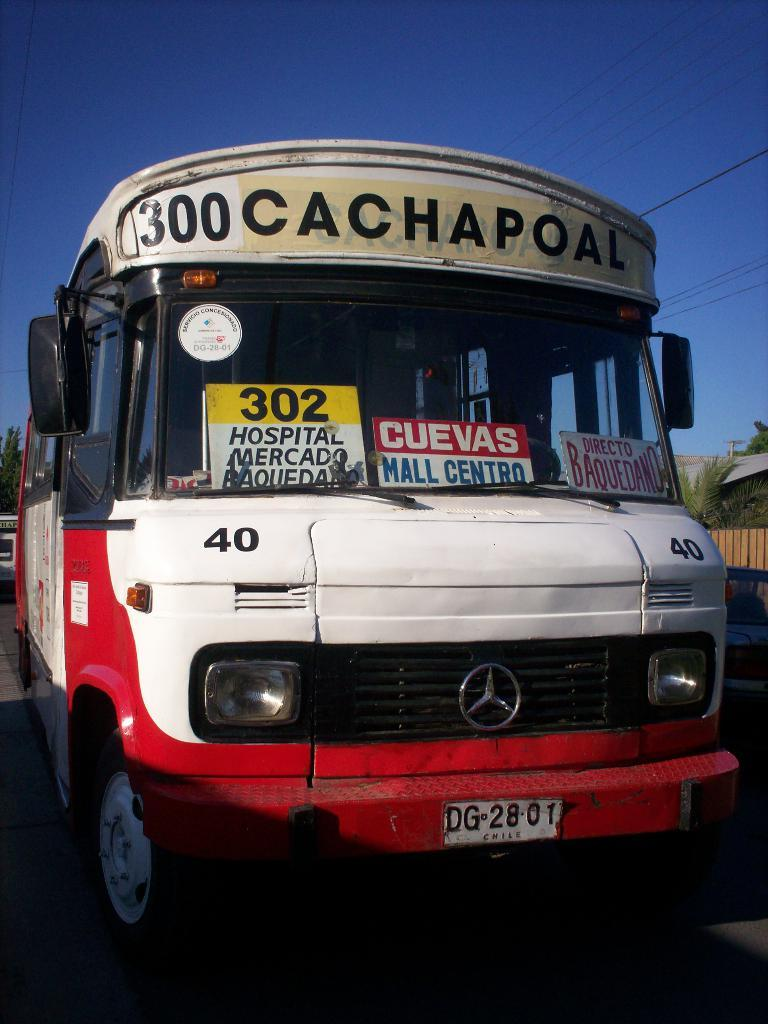What is the main subject of the image? There is a vehicle on the road in the image. What can be seen in the background of the image? There are trees, a fence, a building, a pole, and wires visible in the image. What is the condition of the sky in the image? The sky is visible in the image, and it looks cloudy. What type of chain can be seen connecting the rings in the image? There is no chain or rings present in the image. 